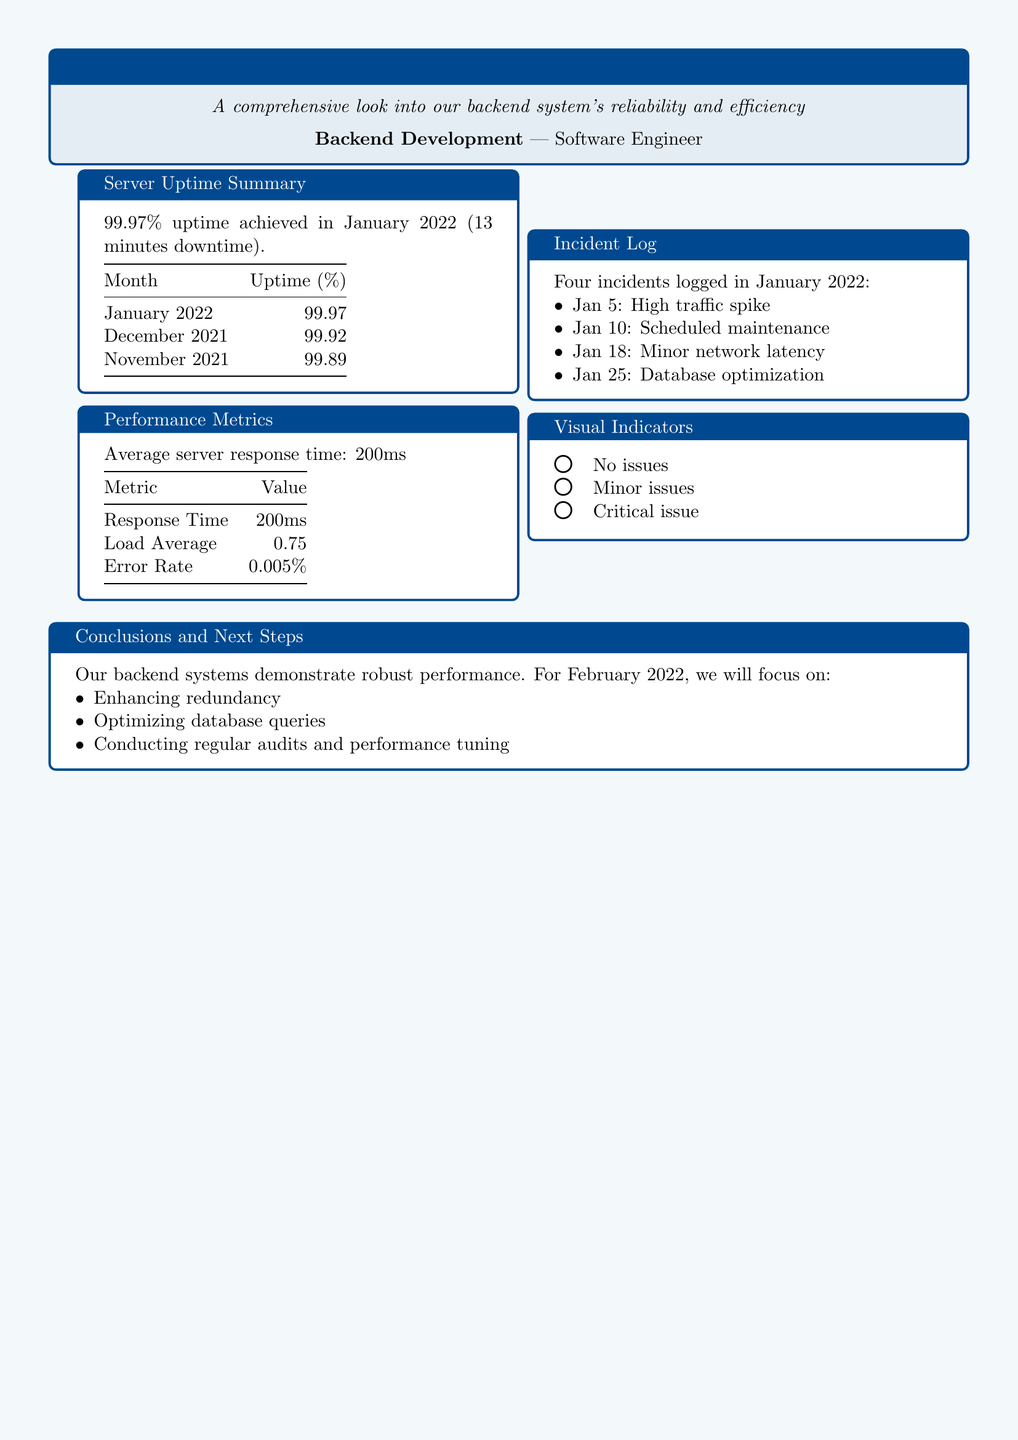What was the server uptime in January 2022? The server uptime is stated as 99.97% in the document.
Answer: 99.97% How many incidents were logged in January 2022? The total number of incidents logged is explicitly mentioned in the incident log section of the document.
Answer: Four What was the average server response time? The average server response time is provided in the performance metrics section.
Answer: 200ms Which incident involved a high traffic spike? The incident logs clearly specify the date and nature of the incident.
Answer: January 5 What is indicated by a green circle in the visual indicators? The visual indicators provide meanings for different colors, including the green circle.
Answer: No issues What focus area is mentioned for February 2022? The conclusions and next steps section lists focus areas for improving the backend systems.
Answer: Enhancing redundancy Which month had a lower uptime, January 2022 or December 2021? The document contains a comparison of uptime percentages for these months.
Answer: December 2021 What is the error rate mentioned in the performance metrics? The performance metrics clearly state the value of the error rate.
Answer: 0.005% 